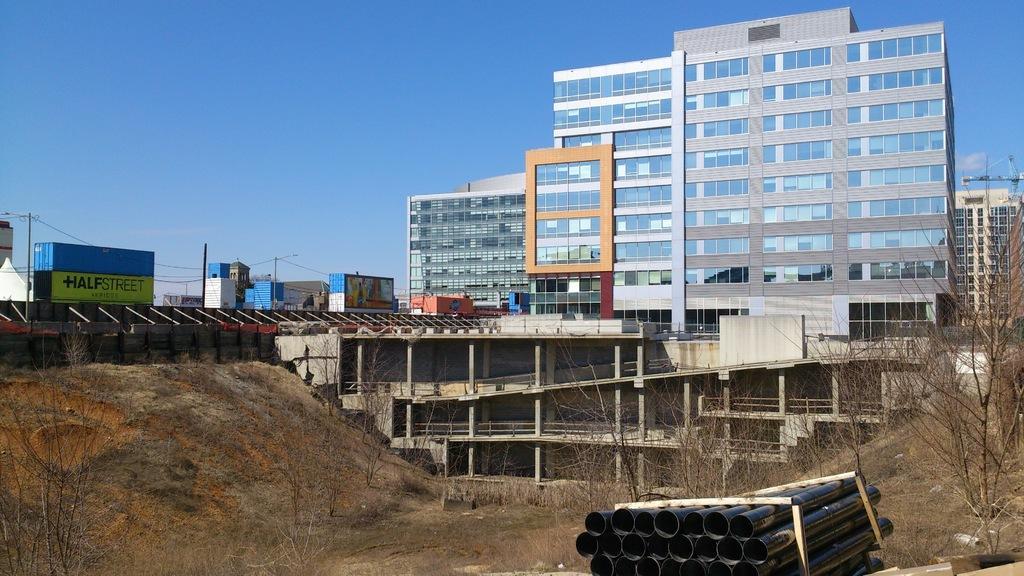Can you describe this image briefly? At the bottom of the picture, we see the pipes or tubes in black color. Beside that, we see a carton box. Beside that, we see dry grass and dry trees. On the left side, we see a hoarding board in green and blue color. Behind that, we see electric poles and wires. There are buildings in the background. At the top, we see the sky. 